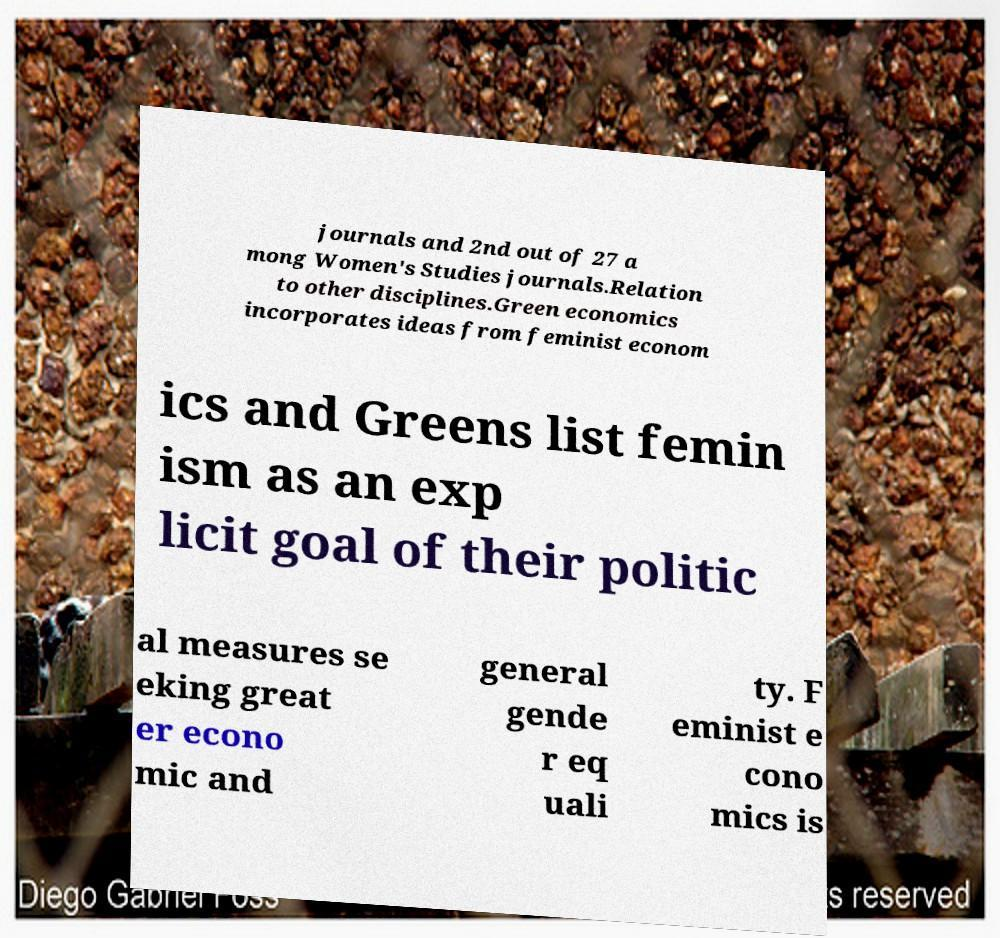Can you read and provide the text displayed in the image?This photo seems to have some interesting text. Can you extract and type it out for me? journals and 2nd out of 27 a mong Women's Studies journals.Relation to other disciplines.Green economics incorporates ideas from feminist econom ics and Greens list femin ism as an exp licit goal of their politic al measures se eking great er econo mic and general gende r eq uali ty. F eminist e cono mics is 